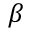Convert formula to latex. <formula><loc_0><loc_0><loc_500><loc_500>\beta</formula> 